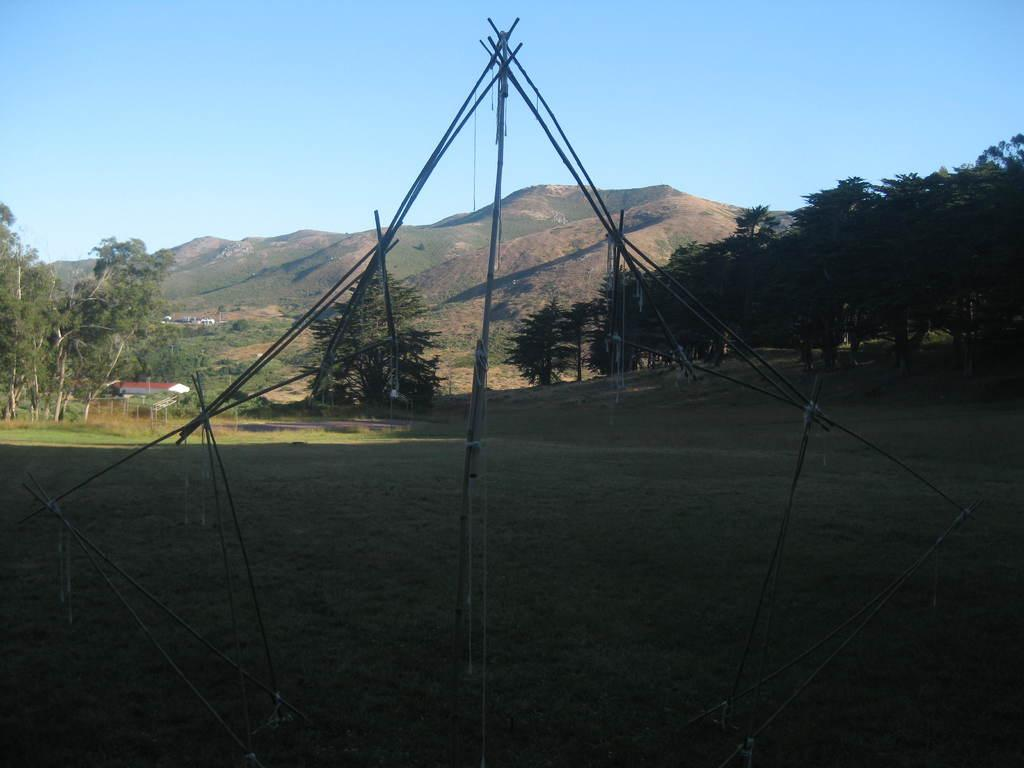What objects are on the ground in the image? There are sticks on the ground in the image. How are the sticks arranged or connected? The sticks are tied together with ropes. What can be seen in the background of the image? There are trees, buildings, mountains, and the sky visible in the background of the image. What type of cherry is being used to cook the sticks in the image? There is no cherry or cooking activity present in the image. How many matches are needed to light the sticks in the image? There are no matches or lighting activity present in the image. 